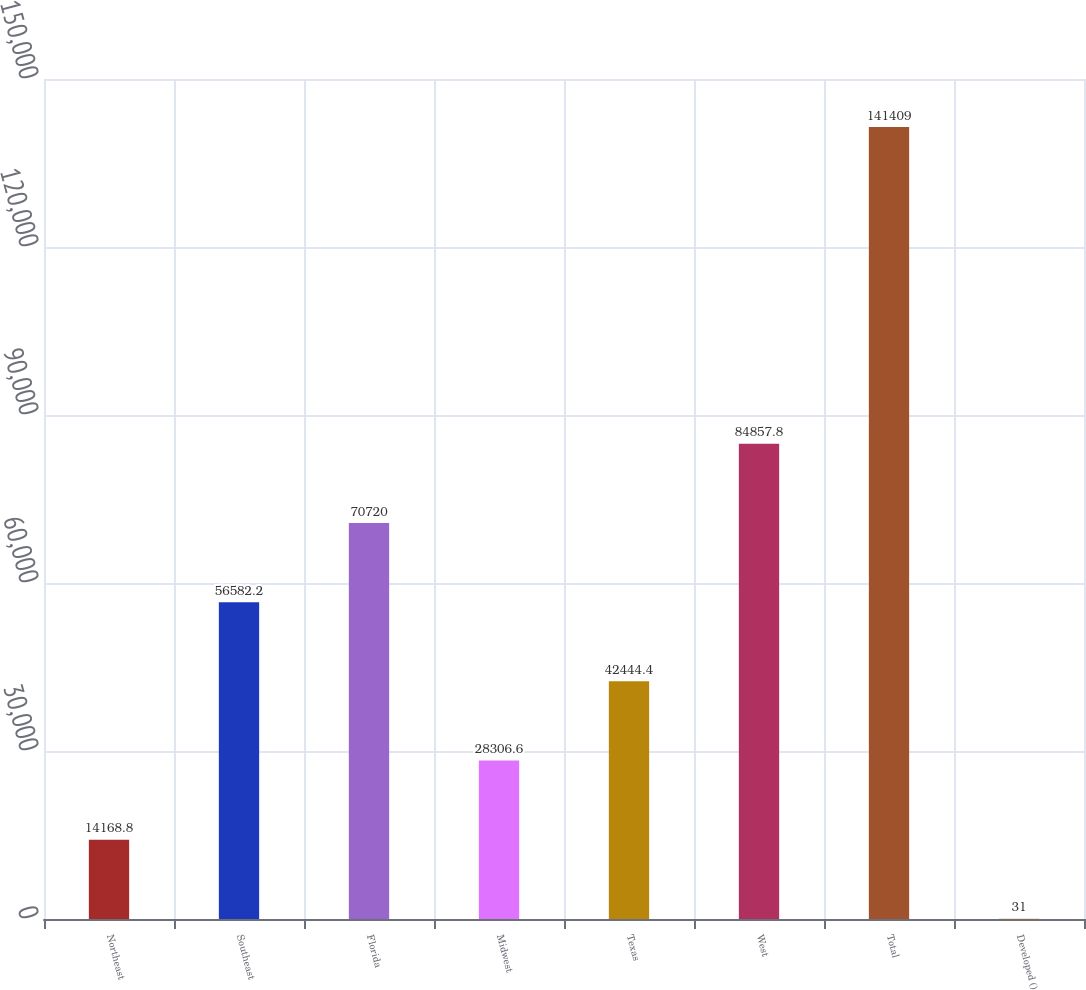<chart> <loc_0><loc_0><loc_500><loc_500><bar_chart><fcel>Northeast<fcel>Southeast<fcel>Florida<fcel>Midwest<fcel>Texas<fcel>West<fcel>Total<fcel>Developed ()<nl><fcel>14168.8<fcel>56582.2<fcel>70720<fcel>28306.6<fcel>42444.4<fcel>84857.8<fcel>141409<fcel>31<nl></chart> 